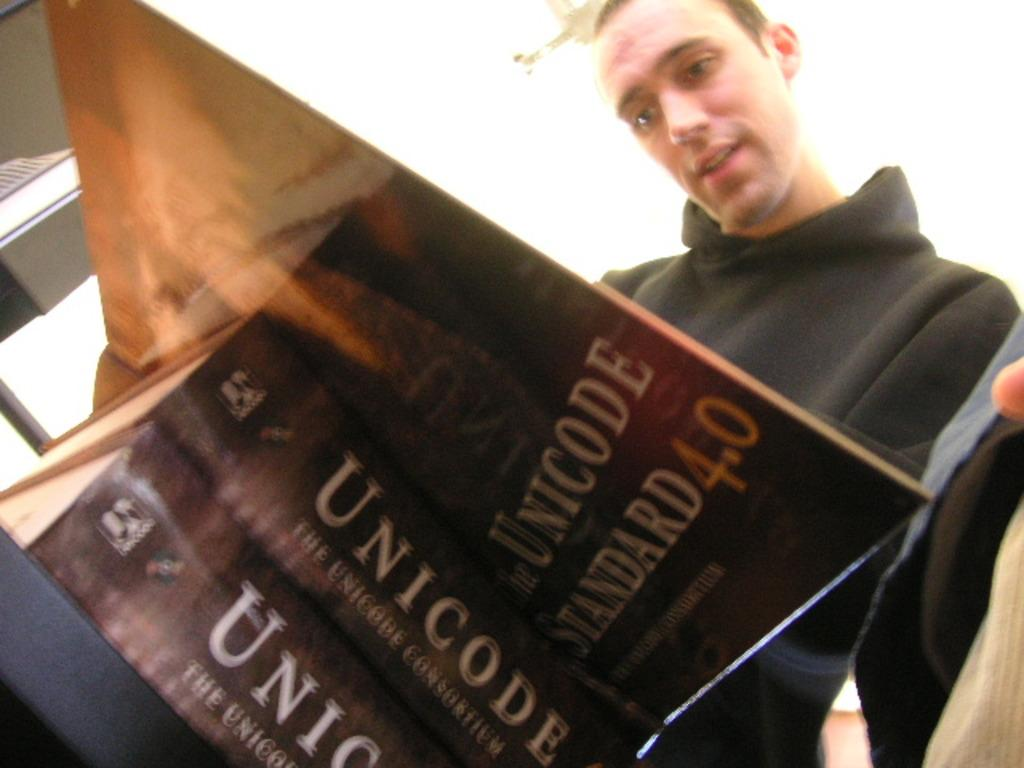<image>
Summarize the visual content of the image. A man reads a thick Unicode standard 4.0 manual. 